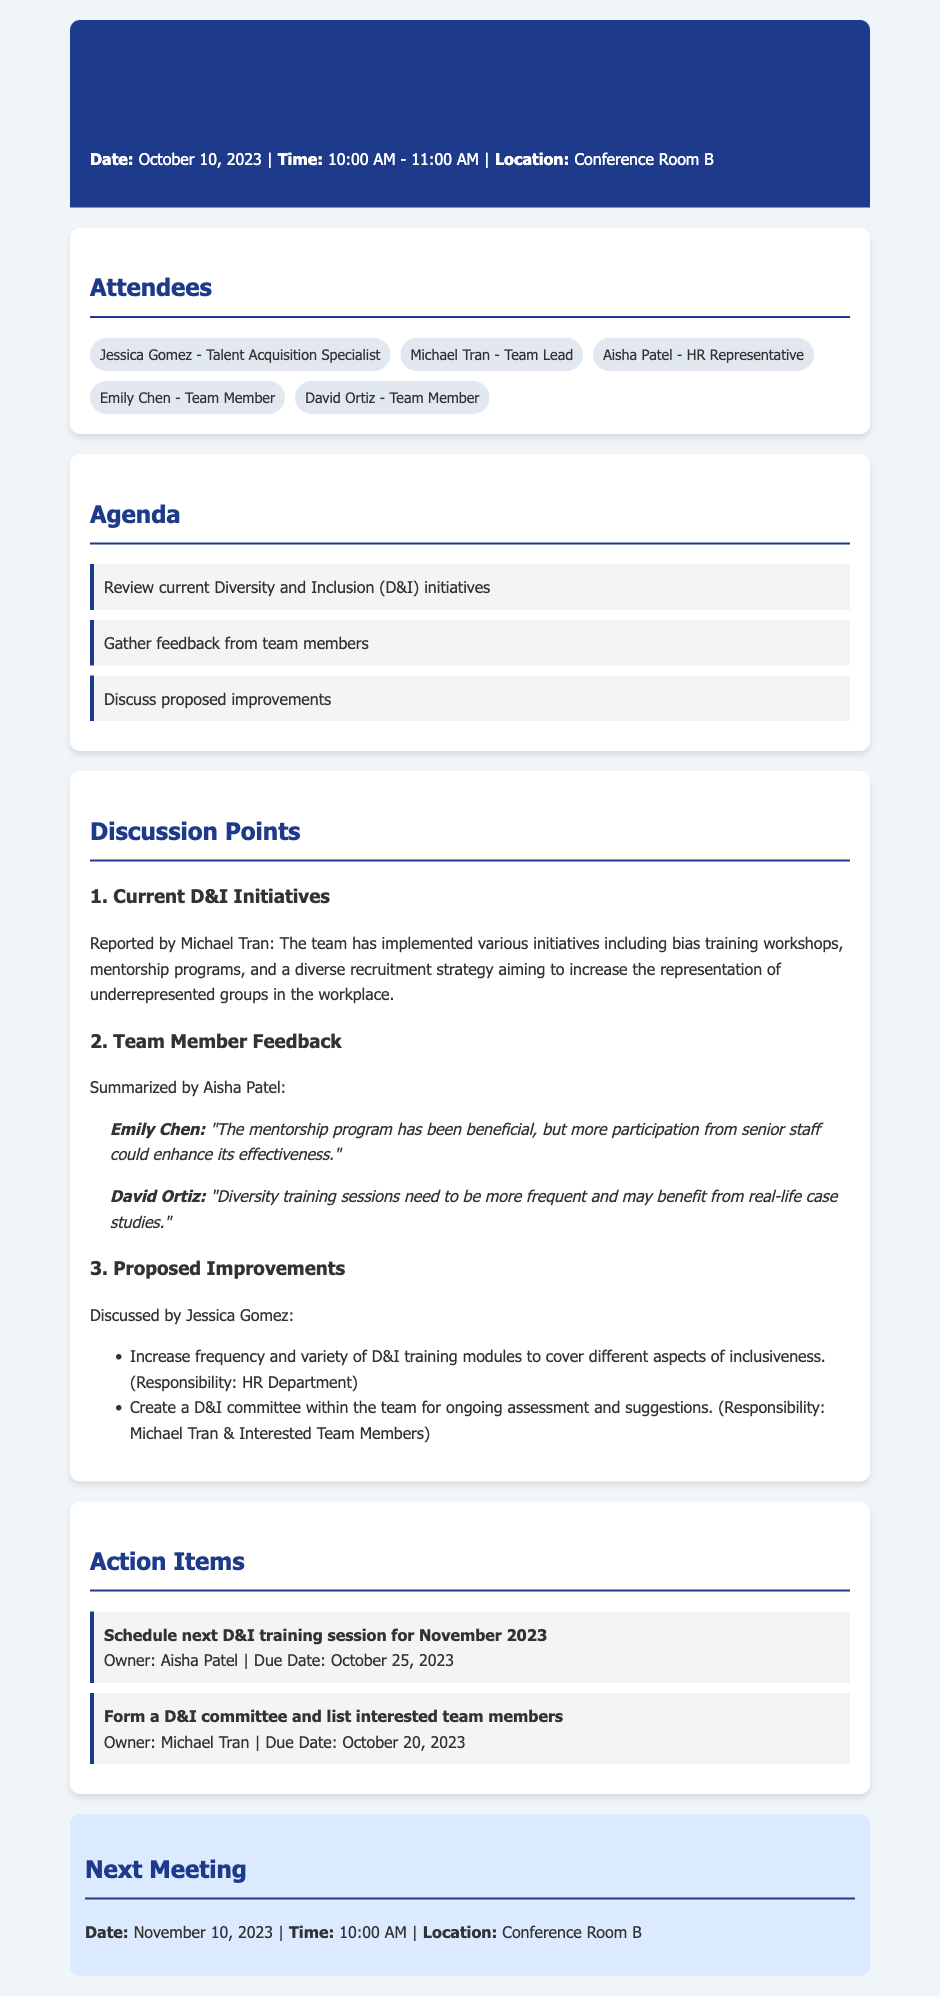What is the date of the meeting? The date of the meeting is mentioned at the beginning of the document.
Answer: October 10, 2023 Who reported on the current D&I initiatives? The individual who reported on the current D&I initiatives is listed under the discussion points.
Answer: Michael Tran How many team members provided feedback during the meeting? The number of team members who provided feedback can be counted from the feedback section.
Answer: 2 What is one of the proposed improvements discussed? The proposed improvements are listed in a bulleted format in the document.
Answer: Increase frequency and variety of D&I training modules Who is responsible for scheduling the next D&I training session? The owner's name is specified in the action items for the next D&I training session.
Answer: Aisha Patel What time is the next meeting scheduled for? The time for the next meeting is included at the end of the document.
Answer: 10:00 AM What is one suggestion made by David Ortiz? The feedback from David Ortiz includes specific suggestions which can be found in the feedback section.
Answer: Diversity training sessions need to be more frequent What is the responsibility of Michael Tran concerning D&I initiatives? The document specifies responsibilities in the proposed improvements section.
Answer: Form a D&I committee and list interested team members 